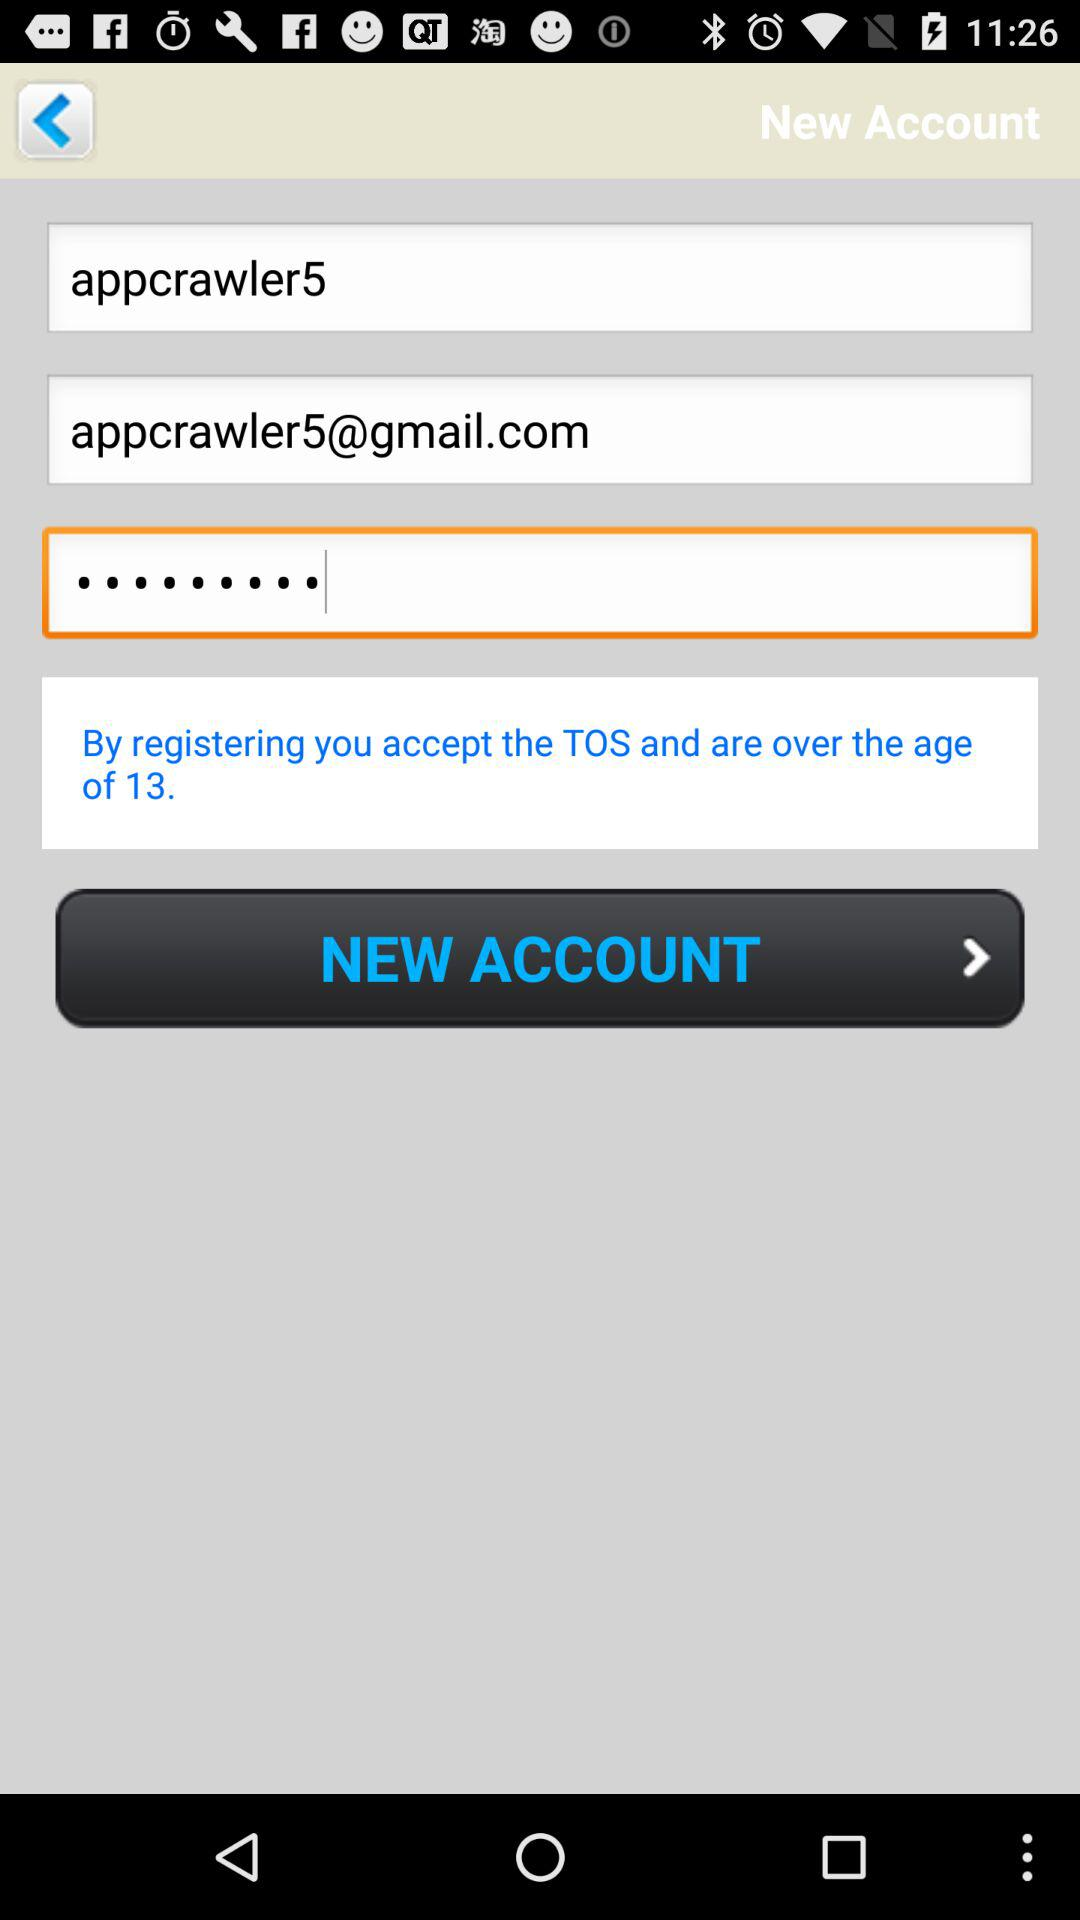What's the name of the user? The name of the user is appcrawler5. 